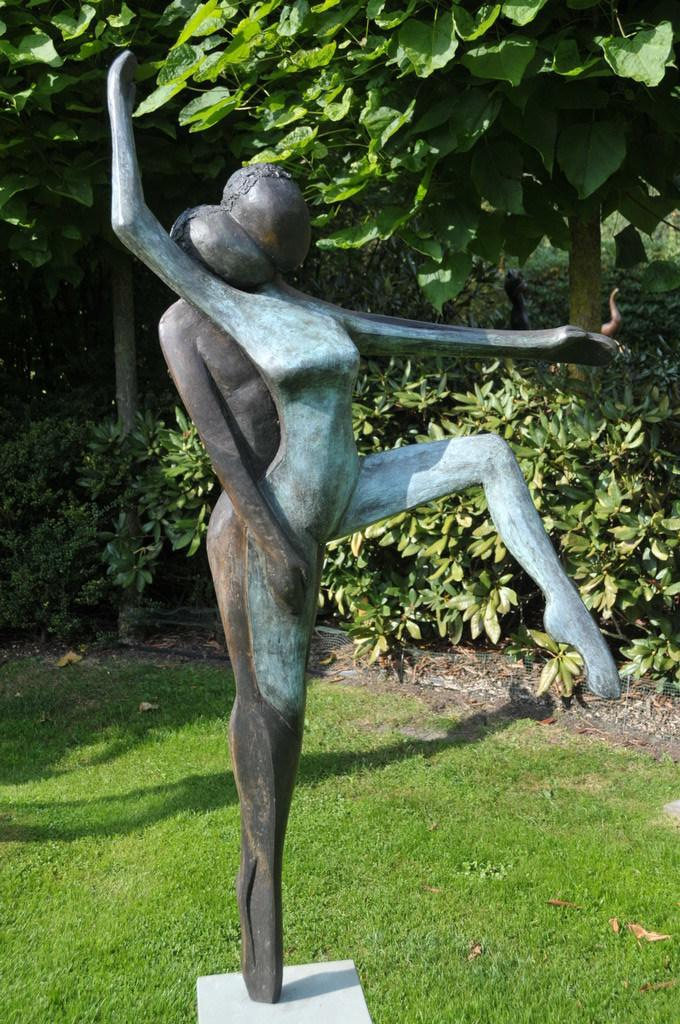What is the main subject of the image? There is a sculpture in the image. Where is the sculpture located? The sculpture is on a rock. What type of vegetation can be seen in the image? There is grass, trees, and small bushes in the image. What book is the sculpture reading in the image? There is no book present in the image, as the main subject is a sculpture on a rock. 